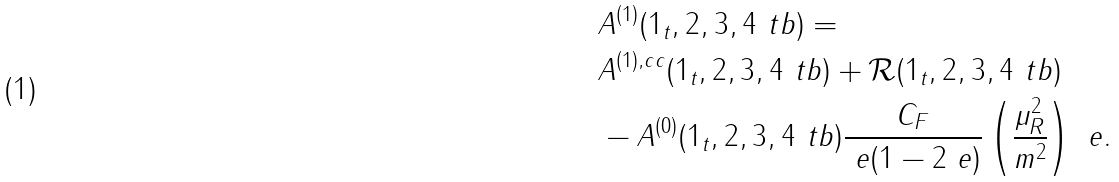Convert formula to latex. <formula><loc_0><loc_0><loc_500><loc_500>& A ^ { ( 1 ) } ( 1 _ { t } , 2 , 3 , 4 _ { \ } t b ) = \\ & A ^ { ( 1 ) , c c } ( 1 _ { t } , 2 , 3 , 4 _ { \ } t b ) + \mathcal { R } ( 1 _ { t } , 2 , 3 , 4 _ { \ } t b ) \\ & - A ^ { ( 0 ) } ( 1 _ { t } , 2 , 3 , 4 _ { \ } t b ) \frac { C _ { F } } { \ e ( 1 - 2 \ e ) } \left ( \frac { \mu _ { R } ^ { 2 } } { m ^ { 2 } } \right ) ^ { \ } e .</formula> 